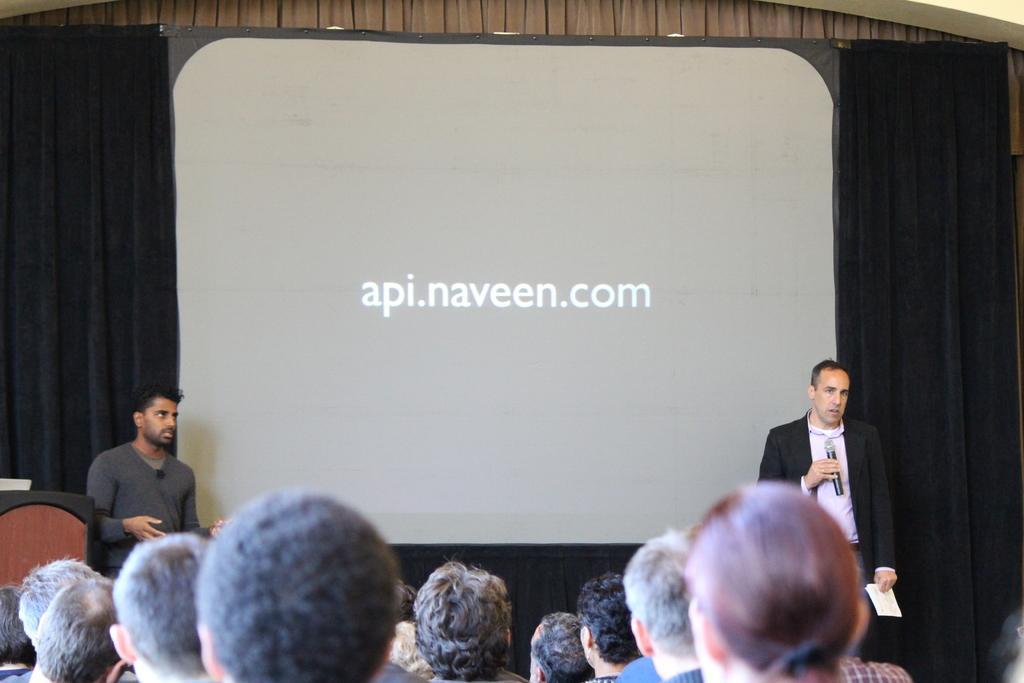Could you give a brief overview of what you see in this image? This picture shows a projector screen and a black curtain on the back and we see couple of men standing and we see a man holding a microphone in one hand and paper in other hand and speaking and we see a podium on the side and we see few people and we see text displaying on the projector screen. 